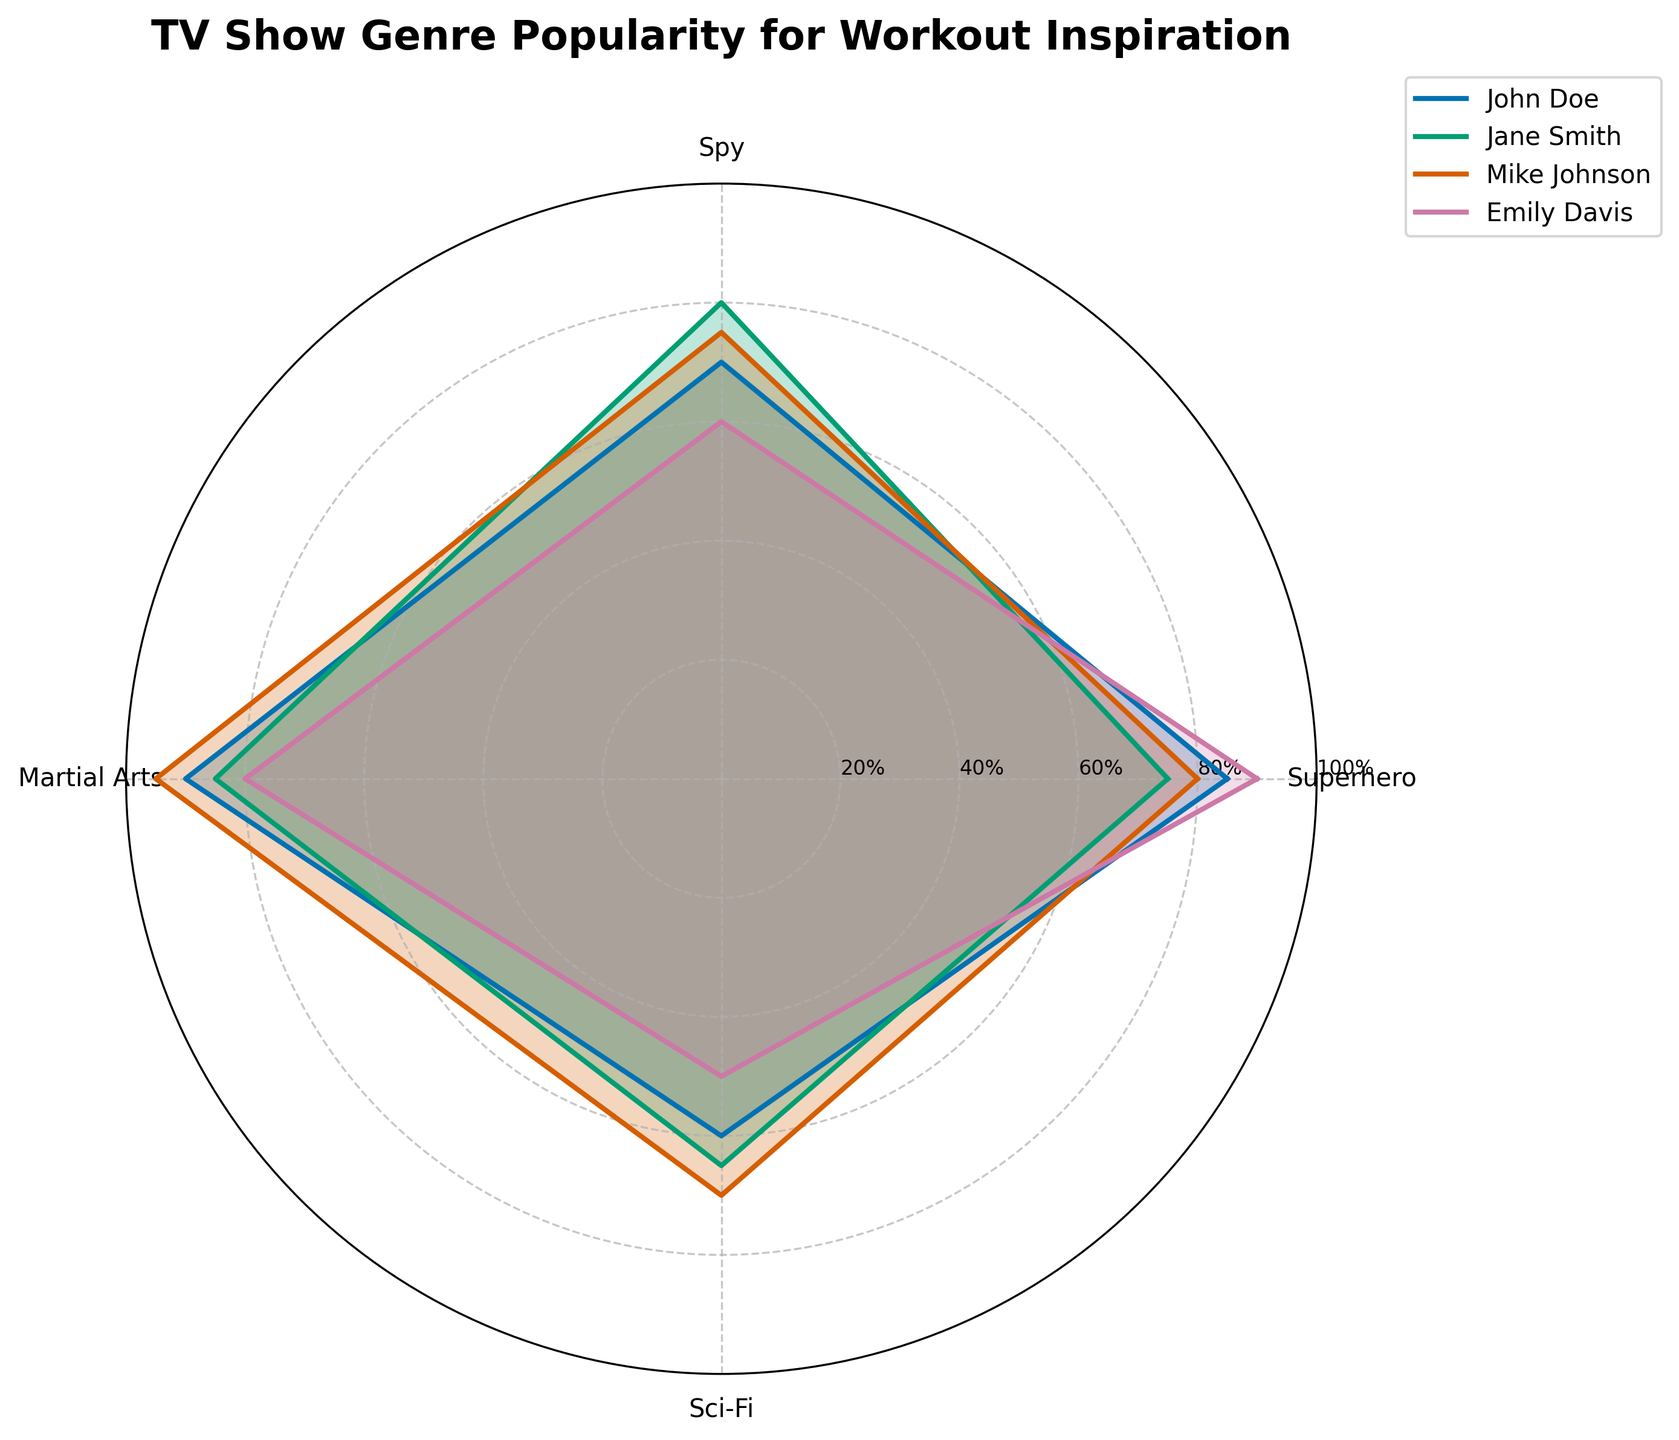what is the highest popularity score for the martial arts genre? Look at the radar chart and observe the values corresponding to the martial arts category. Mike Johnson has the highest score for martial arts at 95.
Answer: 95 Which genre has the lowest popularity among the recorded trainers? Compare the overall lowest scores in each category. The lowest value is 50 for the Sci-Fi genre by Emily Davis.
Answer: Sci-Fi How does Jane Smith's popularity in the spy genre compare to John Doe's? Compare the plotted points for Jane Smith and John Doe in the spy genre. Jane Smith has a higher popularity score of 80 compared to John Doe's 70.
Answer: Jane Smith has a higher popularity What is the total popularity score for Emily Davis across all genres? Sum up the values for Emily Davis across all categories: 90 (superhero) + 60 (spy) + 80 (martial arts) + 50 (Sci-Fi) = 280.
Answer: 280 Which trainer scores the highest in the superhero genre? Compare the scores of all trainers in the superhero genre. Emily Davis has the highest score at 90.
Answer: Emily Davis On average, how popular is the Sci-Fi genre among the trainers? Calculate the mean of each trainer's score for the Sci-Fi genre: (60 + 65 + 70 + 50) / 4 = 61.25.
Answer: 61.25 Which two genres have the closest popularity scores for John Doe? Observe John Doe's scores across all genres, and compare their differences: Superhero (85), Spy (70), Martial Arts (90), Sci-Fi (60). The superhero and martial arts scores are closest with a difference of 90 - 85 = 5.
Answer: Superhero and Martial Arts How does Mike Johnson's average popularity score across all genres compare to Jane Smith's? Calculate the average score for both trainers: Mike Johnson's average is (80 + 75 + 95 + 70) / 4 = 80; Jane Smith's average is (75 + 80 + 85 + 65) / 4 = 76.25.
Answer: Mike Johnson's average is higher What's the range of popularity scores for the spy genre? Identify the highest and lowest values in the spy genre: the highest score is 80 by Jane Smith and the lowest is 60 by Emily Davis. The range is 80 - 60 = 20.
Answer: 20 Do any trainers score below 50 in any genre? Review the plotted scores for all trainers across each genre: all values listed (above 50-95) show no genre scores below 50.
Answer: No 